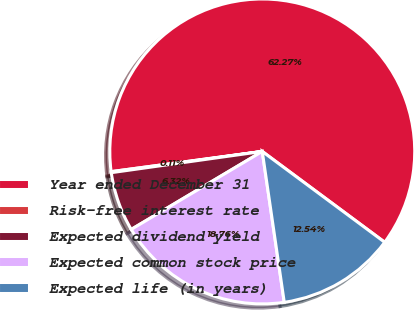Convert chart to OTSL. <chart><loc_0><loc_0><loc_500><loc_500><pie_chart><fcel>Year ended December 31<fcel>Risk-free interest rate<fcel>Expected dividend yield<fcel>Expected common stock price<fcel>Expected life (in years)<nl><fcel>62.27%<fcel>0.11%<fcel>6.32%<fcel>18.76%<fcel>12.54%<nl></chart> 